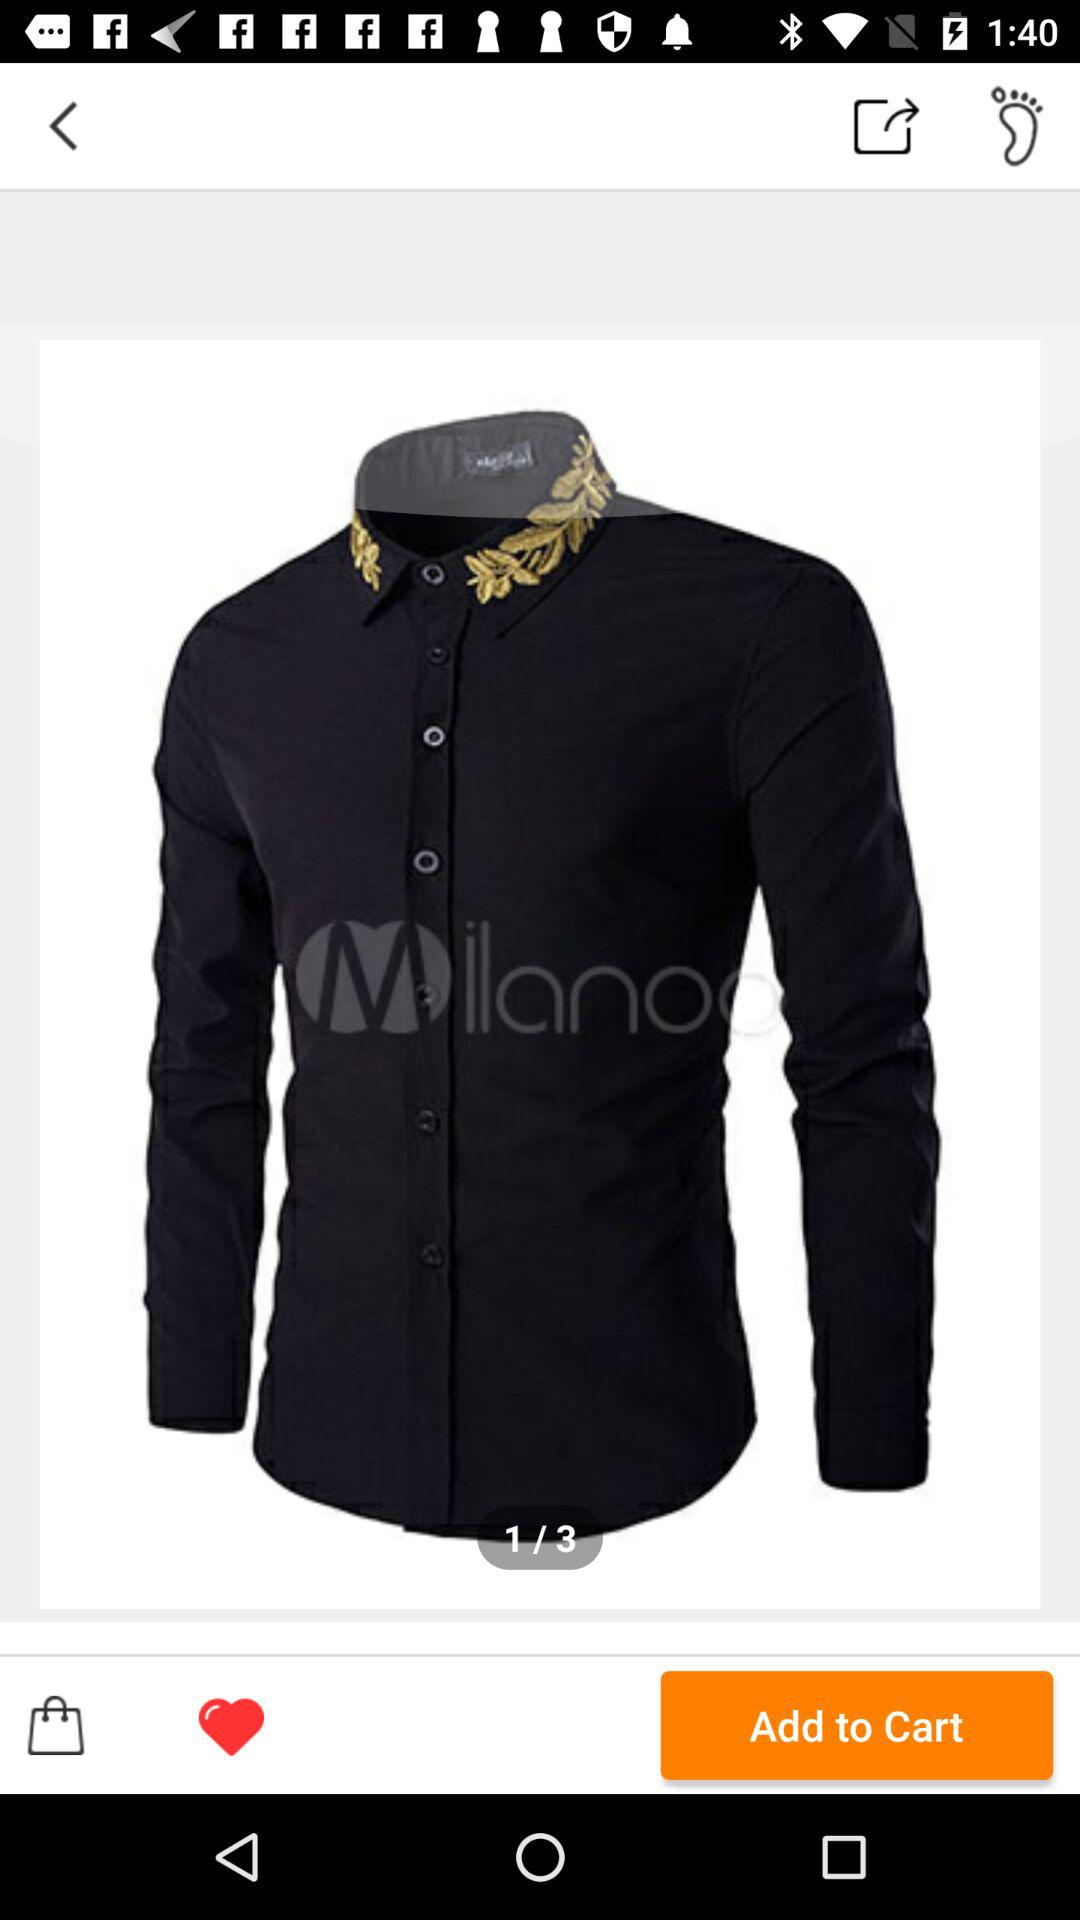In what photo am I currently looking at? You are currently at photo 1. 